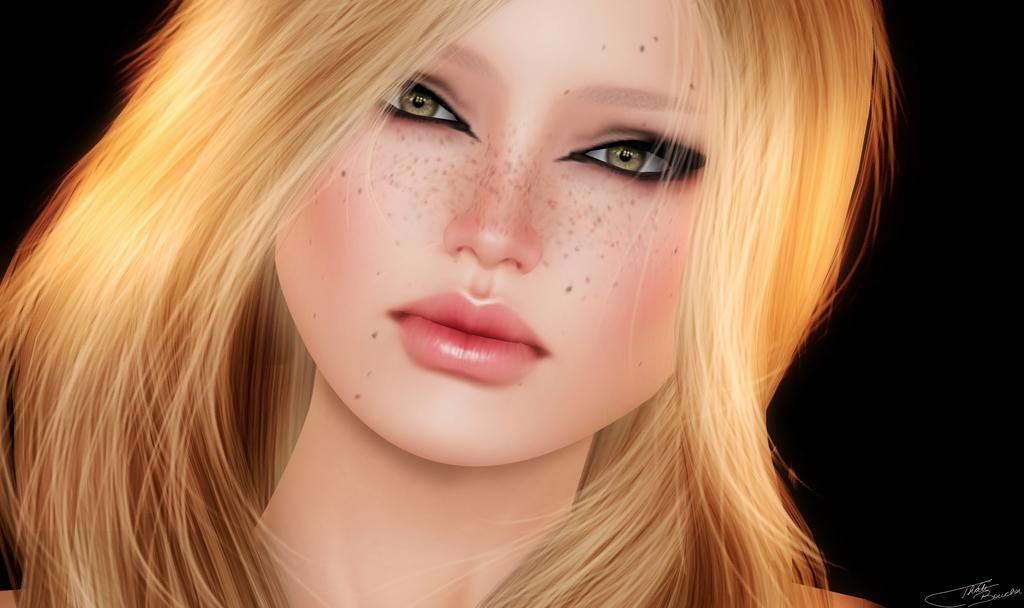What is the main subject of the image? There is a girl in the image. Can you describe the girl's appearance? The girl has red hair. What type of coil does the girl's son use in the image? There is no son present in the image, and therefore no coil can be observed. 